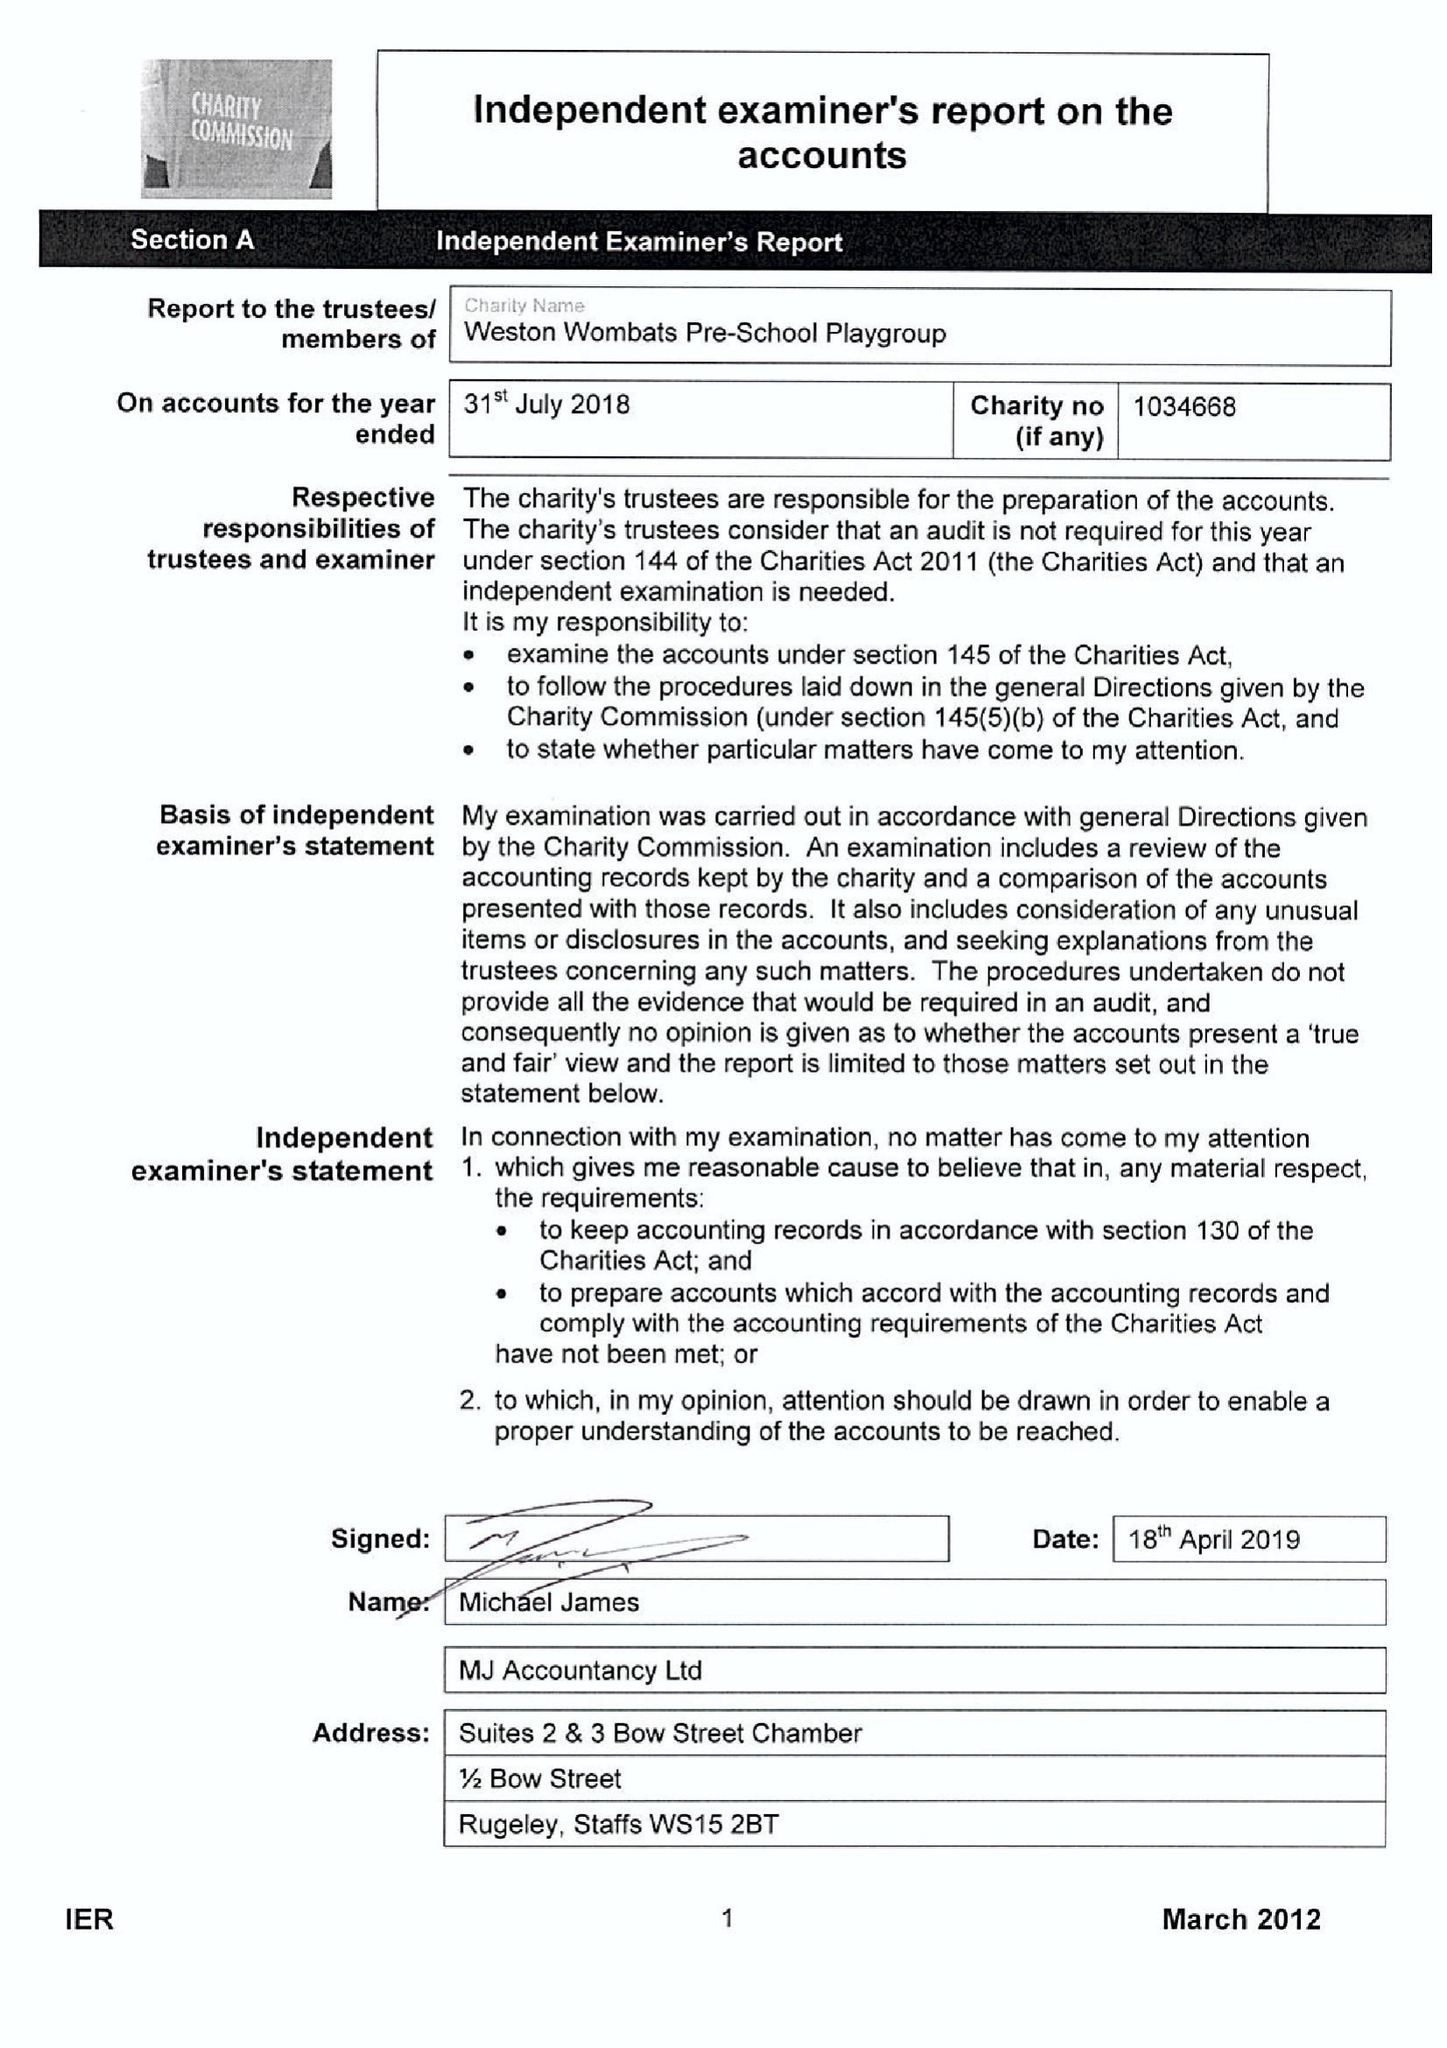What is the value for the spending_annually_in_british_pounds?
Answer the question using a single word or phrase. 28923.00 